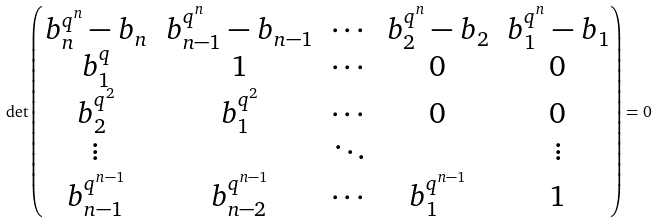<formula> <loc_0><loc_0><loc_500><loc_500>\det \begin{pmatrix} b _ { n } ^ { q ^ { n } } - b _ { n } & b _ { n - 1 } ^ { q ^ { n } } - b _ { n - 1 } & \cdots & b _ { 2 } ^ { q ^ { n } } - b _ { 2 } & b _ { 1 } ^ { q ^ { n } } - b _ { 1 } \\ b _ { 1 } ^ { q } & 1 & \cdots & 0 & 0 \\ b _ { 2 } ^ { q ^ { 2 } } & b _ { 1 } ^ { q ^ { 2 } } & \cdots & 0 & 0 \\ \vdots & & \ddots & & \vdots \\ b _ { n - 1 } ^ { q ^ { n - 1 } } & b _ { n - 2 } ^ { q ^ { n - 1 } } & \cdots & b _ { 1 } ^ { q ^ { n - 1 } } & 1 \end{pmatrix} = 0</formula> 